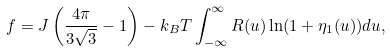Convert formula to latex. <formula><loc_0><loc_0><loc_500><loc_500>f = J \left ( \frac { 4 \pi } { 3 \sqrt { 3 } } - 1 \right ) - k _ { B } T \int _ { - \infty } ^ { \infty } R ( u ) \ln ( 1 + \eta _ { 1 } ( u ) ) d u ,</formula> 